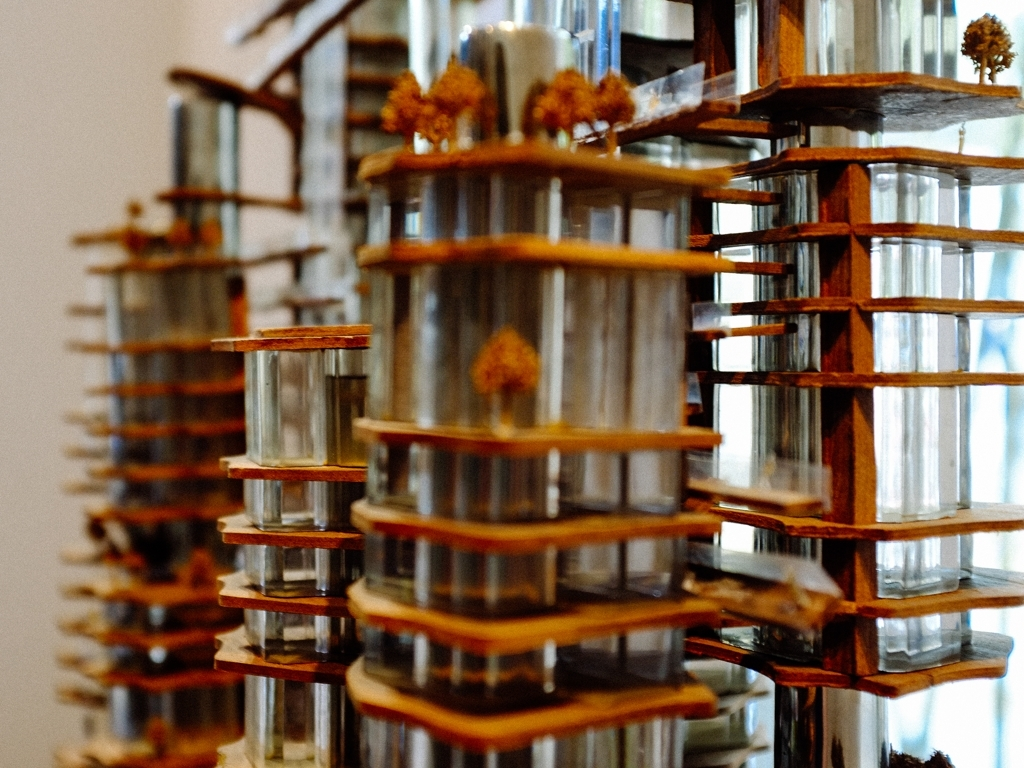Does the repeating pattern in the image serve a particular purpose? The repeating pattern in the image appears to create a sense of rhythm and consistency, which can be visually appealing and symbolically significant. This could mirror themes of replication and uniformity found in urban landscapes or might reflect a concept related to modularity and the efficient use of space in design. It's also possible that the repetition is intended to highlight the subtle differences and variations between the individual elements. How does the focus technique used in this photo affect the perception of the installation? The selective focus technique, where the foreground is in sharp focus while the background fades into a gentle blur, draws the viewer's attention to the detailed craftsmanship of the nearest elements. This heightens the sense of depth and dimensionality, while also creating an almost dreamlike atmosphere that can alter the viewer's perception, making the installation appear more dynamic and complex. 